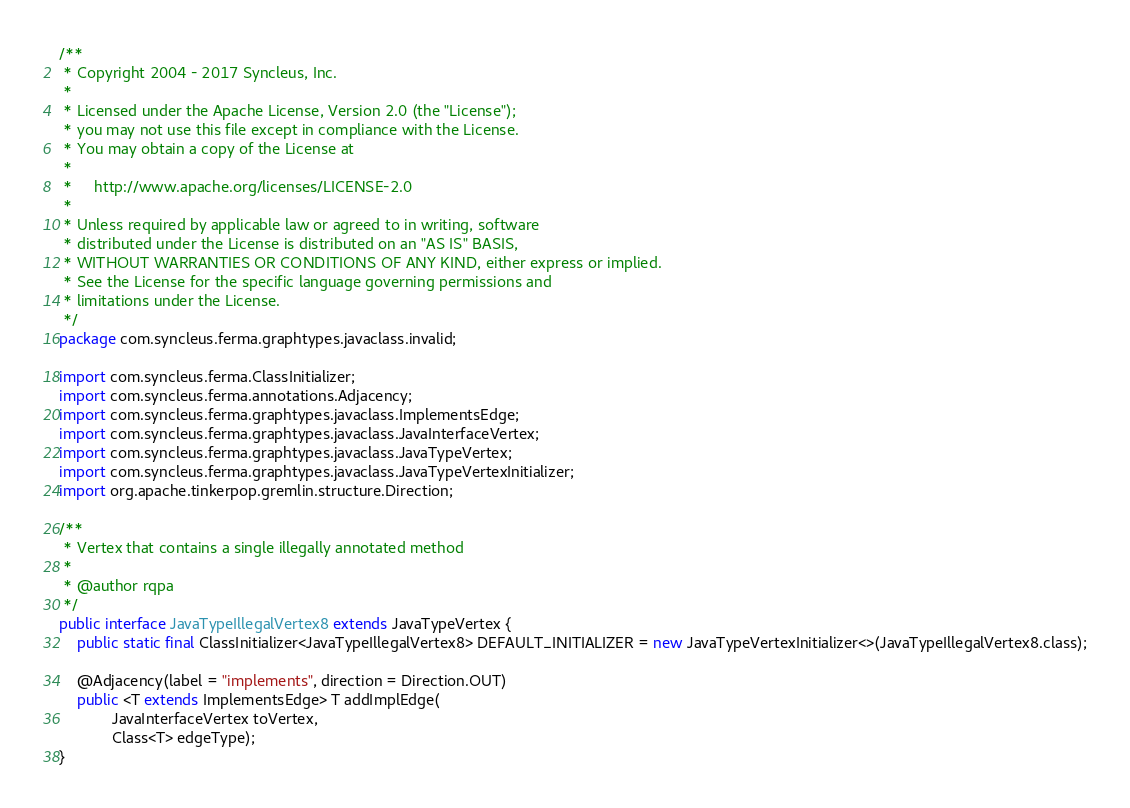Convert code to text. <code><loc_0><loc_0><loc_500><loc_500><_Java_>/**
 * Copyright 2004 - 2017 Syncleus, Inc.
 *
 * Licensed under the Apache License, Version 2.0 (the "License");
 * you may not use this file except in compliance with the License.
 * You may obtain a copy of the License at
 *
 *     http://www.apache.org/licenses/LICENSE-2.0
 *
 * Unless required by applicable law or agreed to in writing, software
 * distributed under the License is distributed on an "AS IS" BASIS,
 * WITHOUT WARRANTIES OR CONDITIONS OF ANY KIND, either express or implied.
 * See the License for the specific language governing permissions and
 * limitations under the License.
 */
package com.syncleus.ferma.graphtypes.javaclass.invalid;

import com.syncleus.ferma.ClassInitializer;
import com.syncleus.ferma.annotations.Adjacency;
import com.syncleus.ferma.graphtypes.javaclass.ImplementsEdge;
import com.syncleus.ferma.graphtypes.javaclass.JavaInterfaceVertex;
import com.syncleus.ferma.graphtypes.javaclass.JavaTypeVertex;
import com.syncleus.ferma.graphtypes.javaclass.JavaTypeVertexInitializer;
import org.apache.tinkerpop.gremlin.structure.Direction;

/**
 * Vertex that contains a single illegally annotated method
 * 
 * @author rqpa
 */
public interface JavaTypeIllegalVertex8 extends JavaTypeVertex {
    public static final ClassInitializer<JavaTypeIllegalVertex8> DEFAULT_INITIALIZER = new JavaTypeVertexInitializer<>(JavaTypeIllegalVertex8.class);
    
    @Adjacency(label = "implements", direction = Direction.OUT)
    public <T extends ImplementsEdge> T addImplEdge(
            JavaInterfaceVertex toVertex, 
            Class<T> edgeType);
}
</code> 